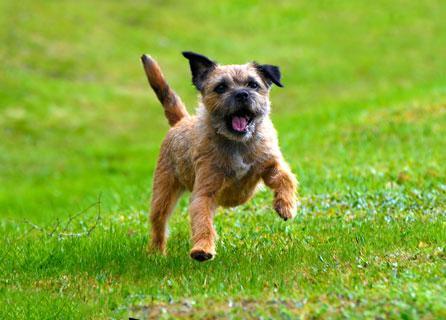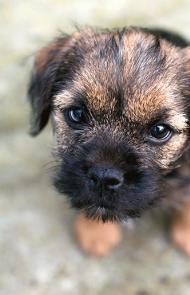The first image is the image on the left, the second image is the image on the right. For the images shown, is this caption "In one image a dog is in the grass, moving forward with its left leg higher than the right and has its mouth open." true? Answer yes or no. Yes. 